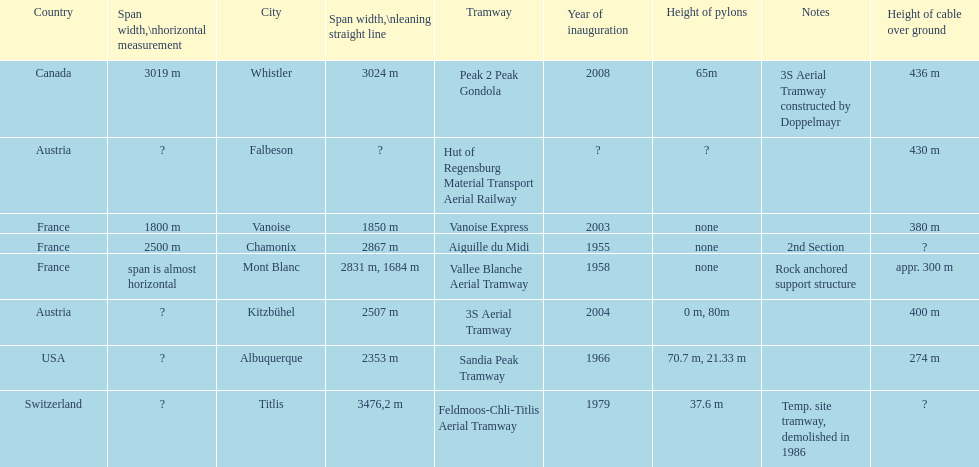At least how many aerial tramways were inaugurated after 1970? 4. 